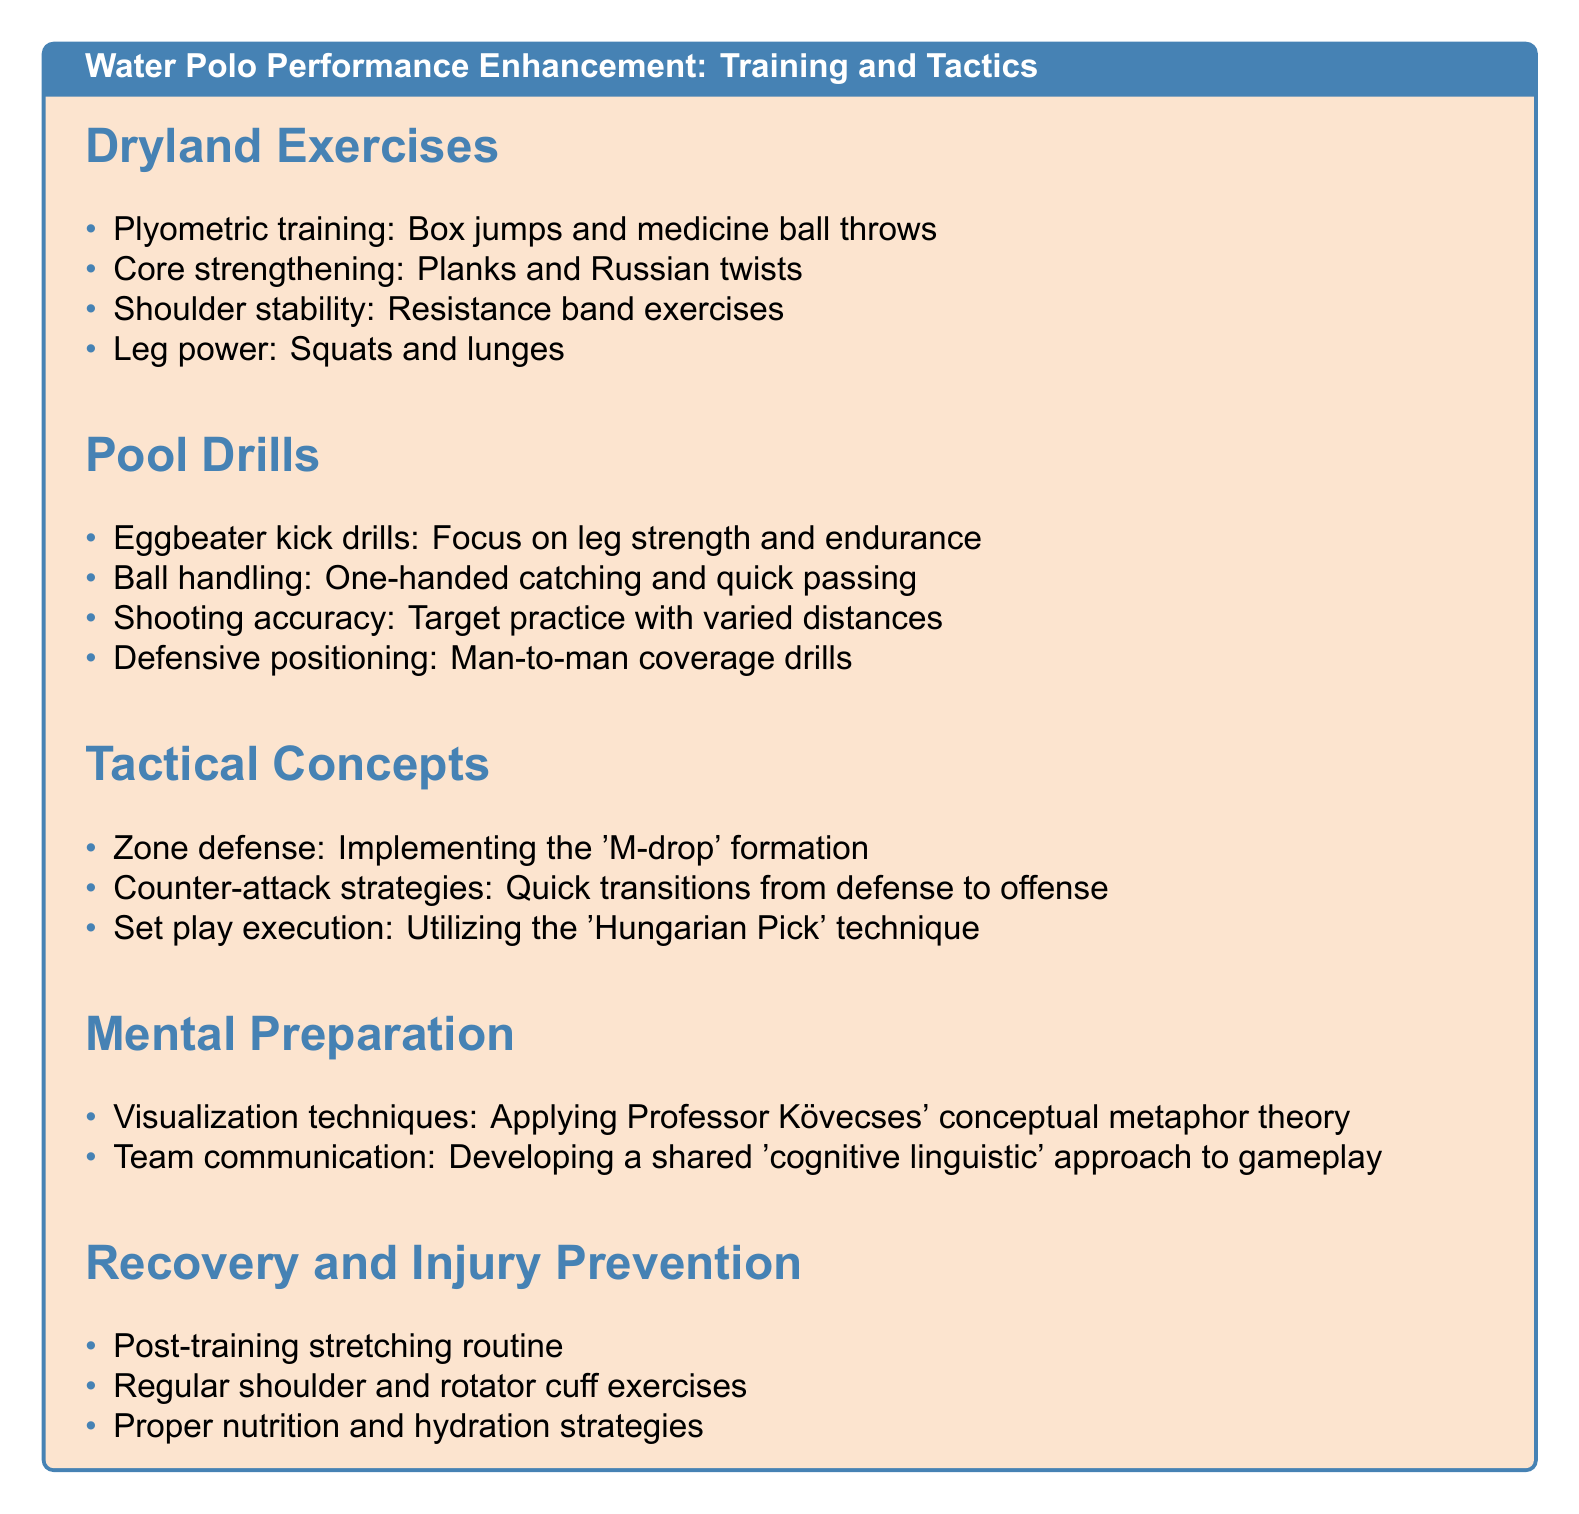What is the first dryland exercise listed? The first item under Dryland Exercises is provided as a list. The first exercise mentioned is "Plyometric training: Box jumps and medicine ball throws."
Answer: Plyometric training: Box jumps and medicine ball throws How many pool drills are there? The section Pool Drills contains a list of items, from which we can count that there are four drills mentioned.
Answer: 4 What technique is utilized in set play execution? The document specifies that the 'Hungarian Pick' technique is used for set play execution.
Answer: Hungarian Pick Which exercise focuses on shoulder stability? The document lists shoulder stability exercises and specifies "Resistance band exercises" as the type focused on shoulder stability.
Answer: Resistance band exercises What is one tactical concept described? The Tactical Concepts section includes three strategies, and one of them provided is "Zone defense: Implementing the 'M-drop' formation."
Answer: Zone defense What should be included in the post-training routine? The document states that a "Post-training stretching routine" should be part of the recovery process after training.
Answer: Post-training stretching routine What visualization theory does the document reference? The Mental Preparation section mentions using "Professor Kövecses' conceptual metaphor theory" for visualization techniques.
Answer: Professor Kövecses' conceptual metaphor theory What is emphasized for team communication? The Cognitive Linguistic aspect of gameplay is highlighted in the team communication strategies as a focus for development.
Answer: Cognitive linguistic approach 